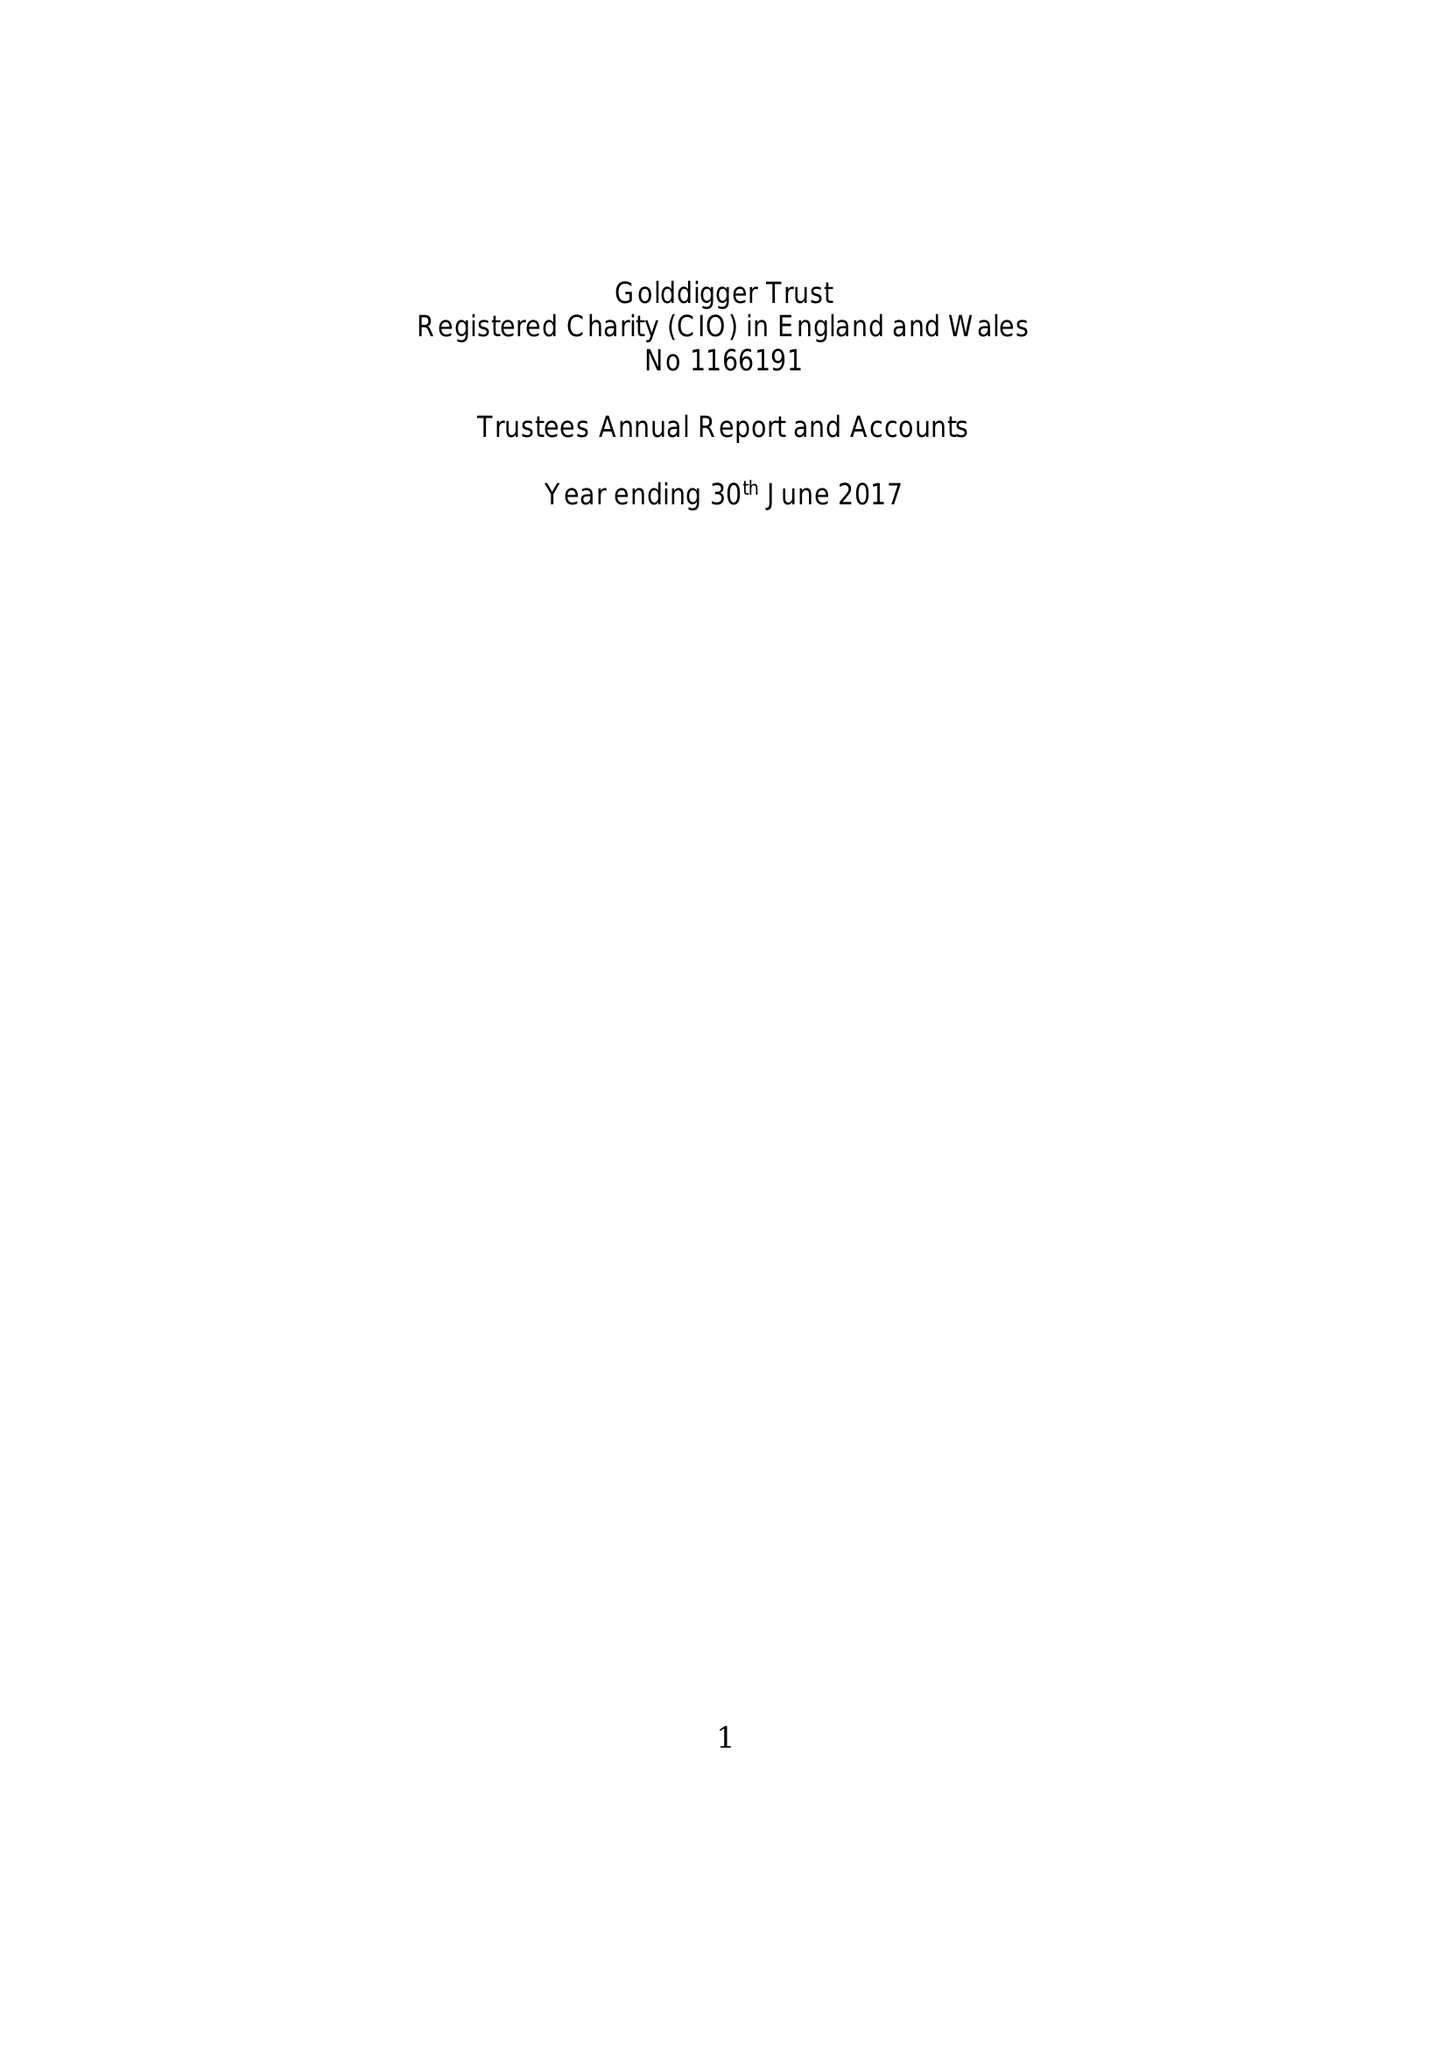What is the value for the address__post_town?
Answer the question using a single word or phrase. SHEFFIELD 